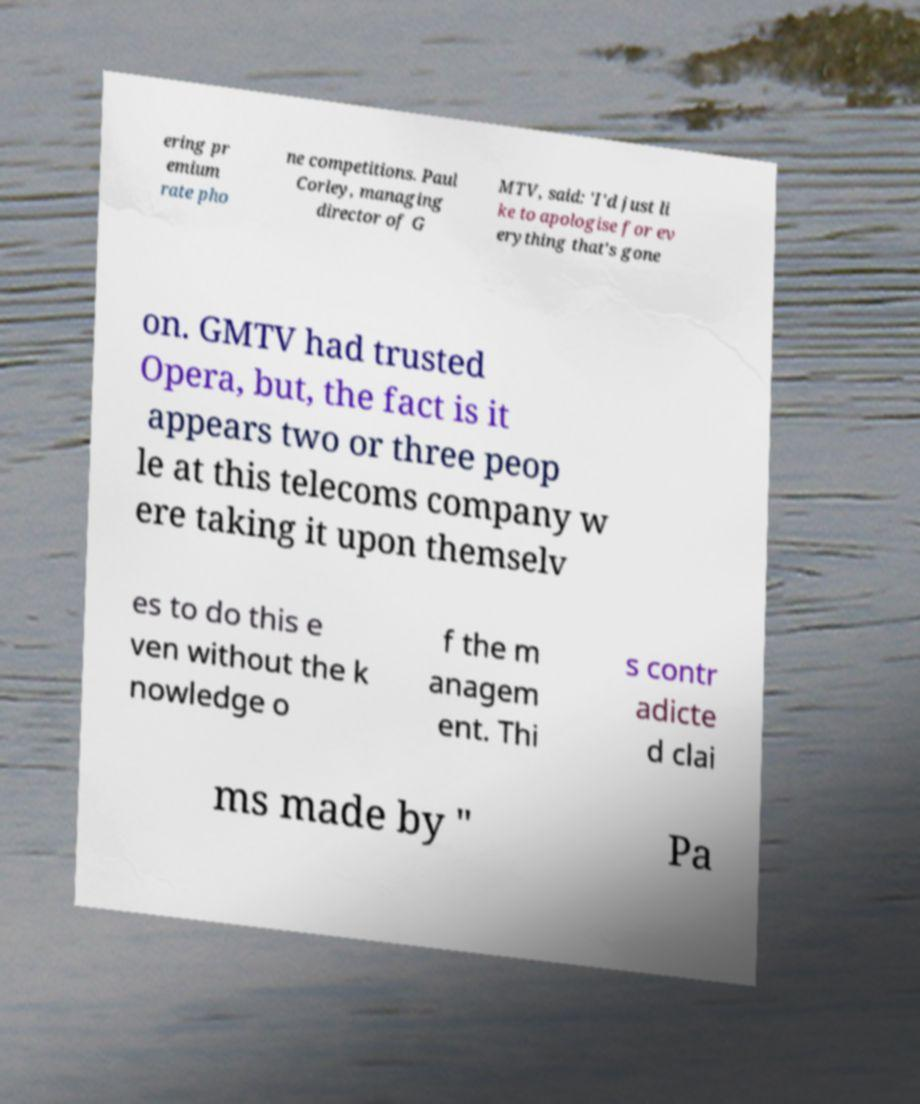There's text embedded in this image that I need extracted. Can you transcribe it verbatim? ering pr emium rate pho ne competitions. Paul Corley, managing director of G MTV, said: 'I'd just li ke to apologise for ev erything that's gone on. GMTV had trusted Opera, but, the fact is it appears two or three peop le at this telecoms company w ere taking it upon themselv es to do this e ven without the k nowledge o f the m anagem ent. Thi s contr adicte d clai ms made by " Pa 